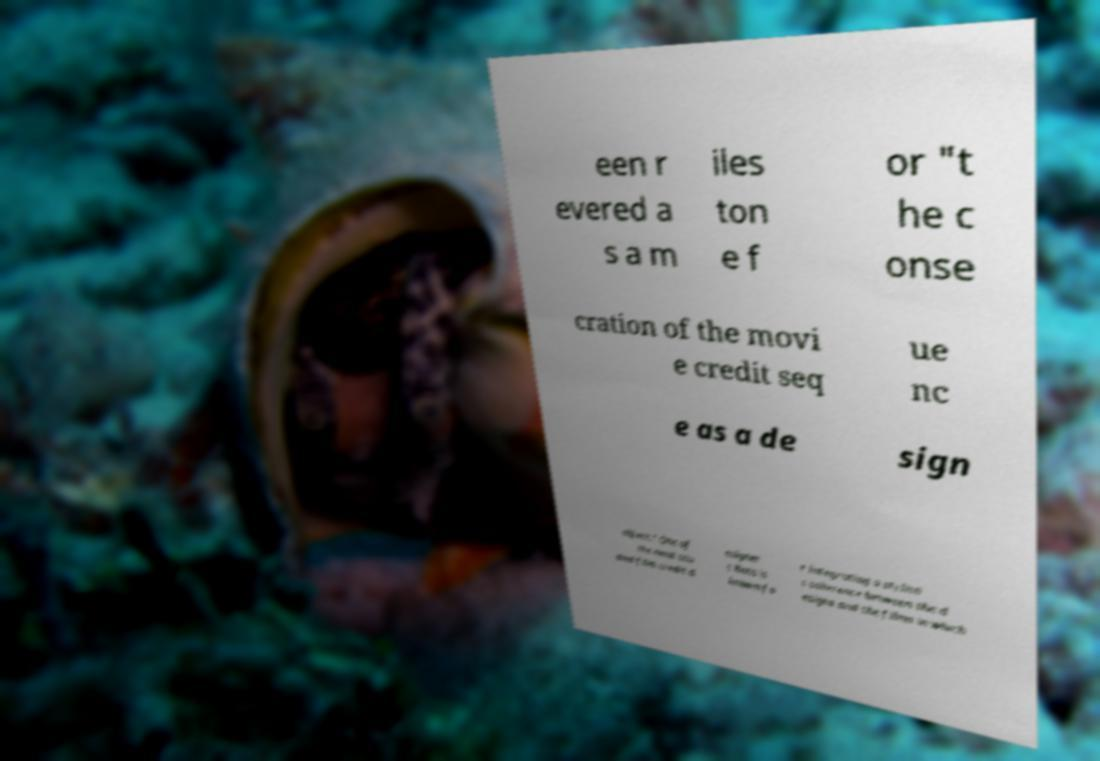Can you read and provide the text displayed in the image?This photo seems to have some interesting text. Can you extract and type it out for me? een r evered a s a m iles ton e f or "t he c onse cration of the movi e credit seq ue nc e as a de sign object." One of the most stu died film credit d esigner s Bass is known fo r integrating a stylisti c coherence between the d esigns and the films in which 